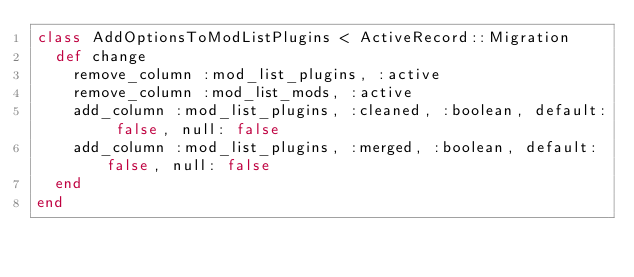<code> <loc_0><loc_0><loc_500><loc_500><_Ruby_>class AddOptionsToModListPlugins < ActiveRecord::Migration
  def change
    remove_column :mod_list_plugins, :active
    remove_column :mod_list_mods, :active
    add_column :mod_list_plugins, :cleaned, :boolean, default: false, null: false
    add_column :mod_list_plugins, :merged, :boolean, default: false, null: false
  end
end
</code> 